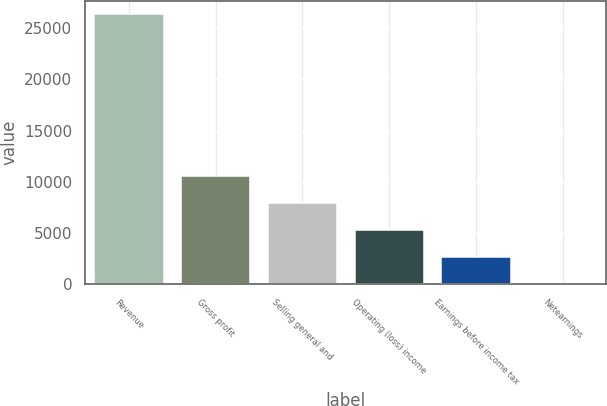Convert chart. <chart><loc_0><loc_0><loc_500><loc_500><bar_chart><fcel>Revenue<fcel>Gross profit<fcel>Selling general and<fcel>Operating (loss) income<fcel>Earnings before income tax<fcel>Netearnings<nl><fcel>26323<fcel>10544.2<fcel>7914.4<fcel>5284.6<fcel>2654.8<fcel>25<nl></chart> 